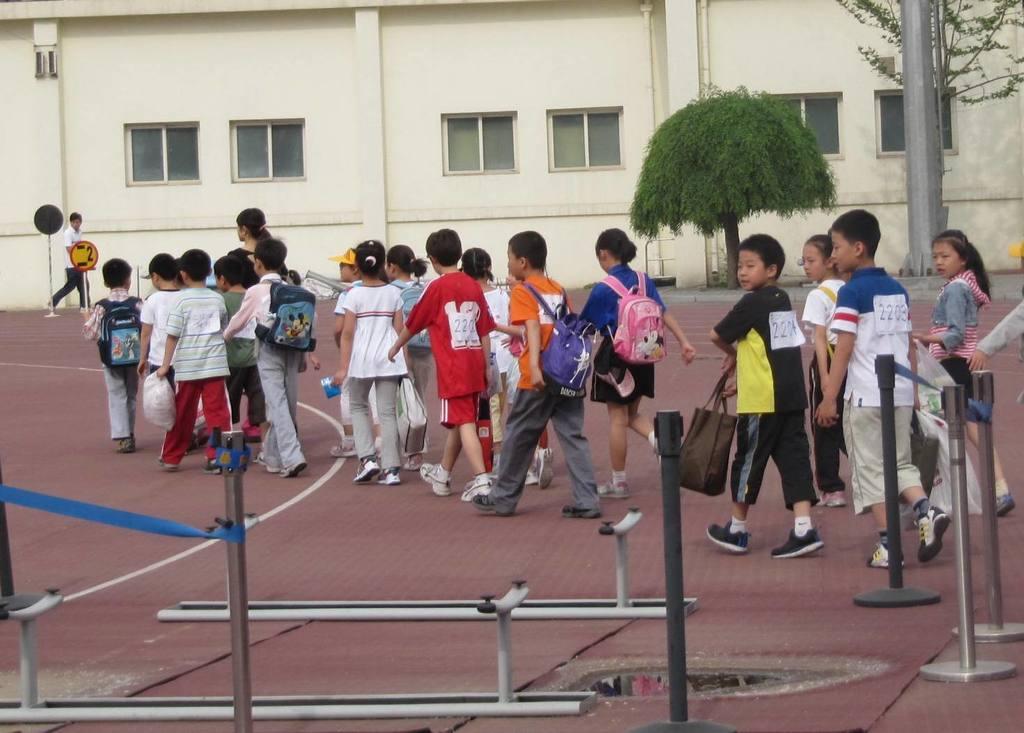In one or two sentences, can you explain what this image depicts? Here we can see group of people. There are poles, boards, and trees. In the background we can see a building and windows. 